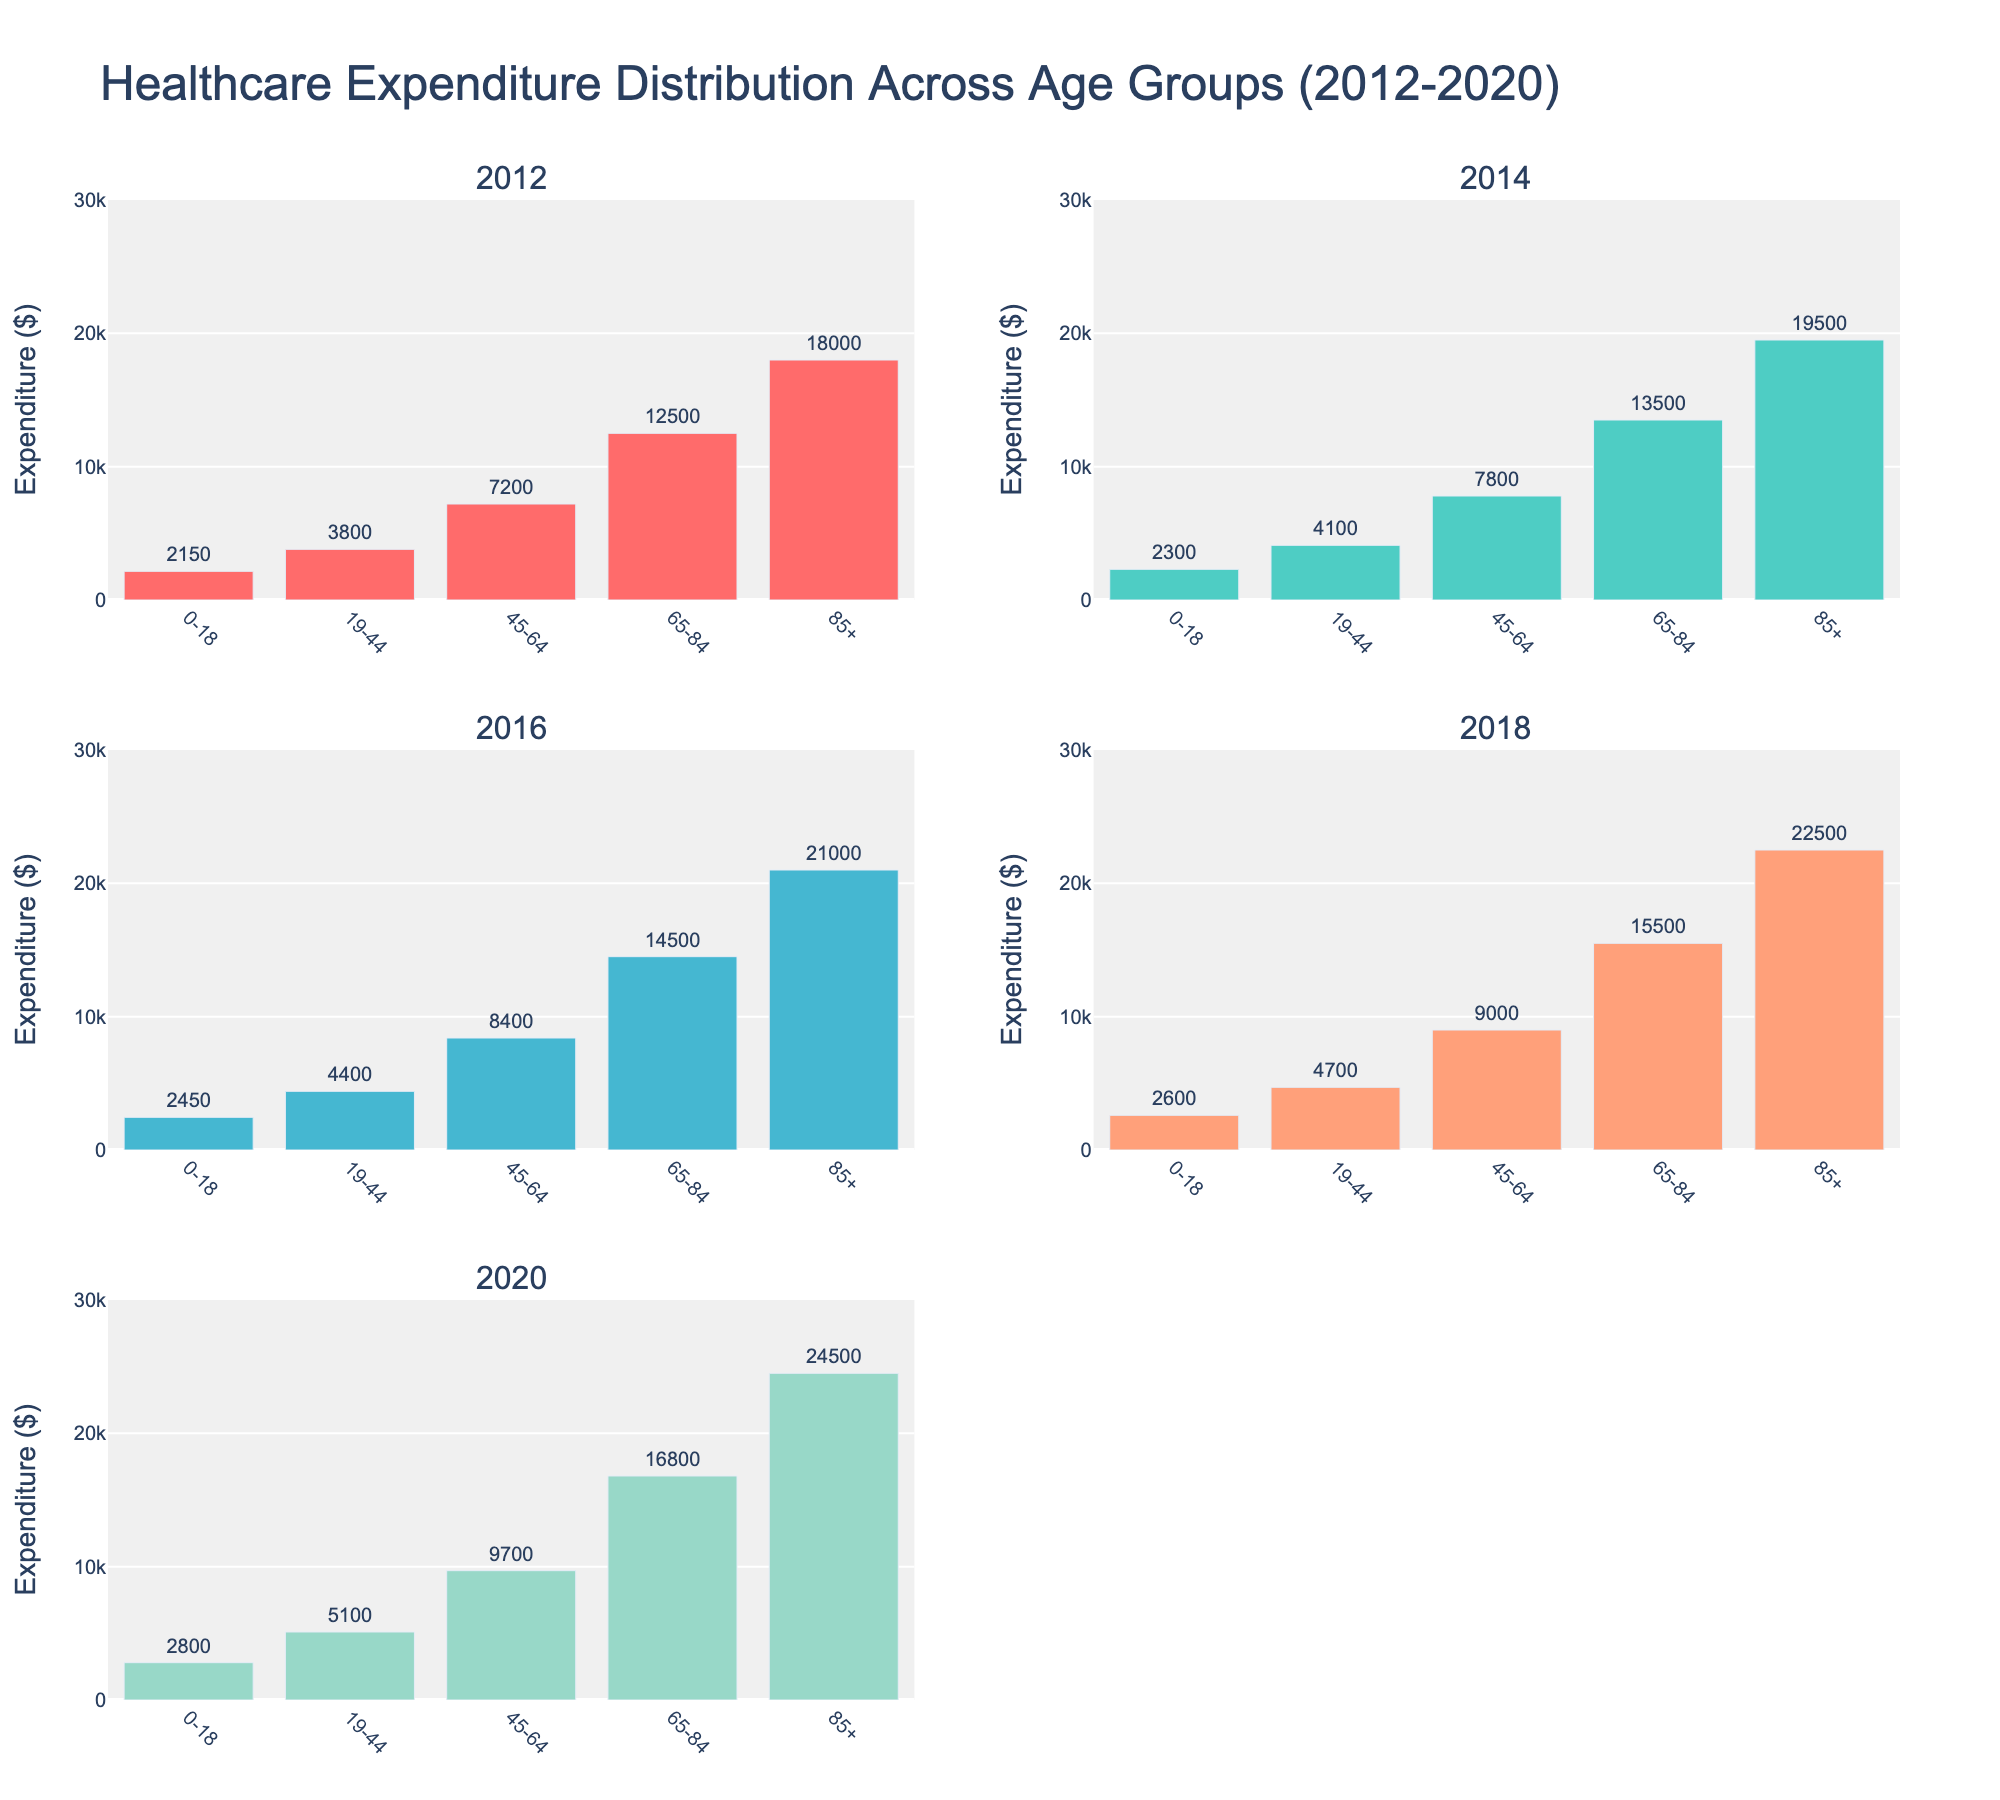What is the title of the figure? The title is located at the top of the figure and it summarizes what the data visualizes. The title is "Healthcare Expenditure Distribution Across Age Groups (2012-2020)"
Answer: Healthcare Expenditure Distribution Across Age Groups (2012-2020) How many subplots are there in the figure? By counting the individual plots within the overall figure, there are 5 subplots present, and each one corresponds to a different year (2012, 2014, 2016, 2018, 2020)
Answer: 5 Which age group had the highest healthcare expenditure in 2012? By examining the first subplot for the year 2012, the bar corresponding to the age group "85+" has the highest value
Answer: 85+ Which year showed the highest expenditure for the age group 65-84? Refer to each subplot focusing specifically on the "65-84" group bars and compare the heights. The year 2020 has the highest expenditure for this age group
Answer: 2020 What's the difference in healthcare expenditure for the age group 45-64 between 2012 and 2020? Find the value for the age group "45-64" in both 2012 and 2020 from the bars. The expenditure in 2012 is 7200 and in 2020 is 9700. The difference is 9700 - 7200 = 2500
Answer: 2500 Which age group has consistently shown an increase in healthcare expenditure from 2012 to 2020? By looking at each subplot year by year for consistent trends, all age groups show an increasing trend, but a significantly noticeable increase is in the "85+" group
Answer: 85+ By how much did the healthcare expenditure for the 0-18 age group increase from 2012 to 2020? Examine the bar heights for 0-18 in 2012 and 2020. The values are 2150 in 2012 and 2800 in 2020. Increase is 2800 - 2150 = 650
Answer: 650 Which age group saw the largest absolute increase in healthcare expenditure from 2018 to 2020? Compare the changes in expenditures between 2018 and 2020 for each category. The increase for "85+" is from 22500 to 24500, which is the largest absolute increase of 2000
Answer: 85+ What is the color of the bar representing the year 2014 in the subplots? Each year is represented by a unique color. The color for the year 2014 is the second color in the sequence, which is a shade of teal
Answer: teal 